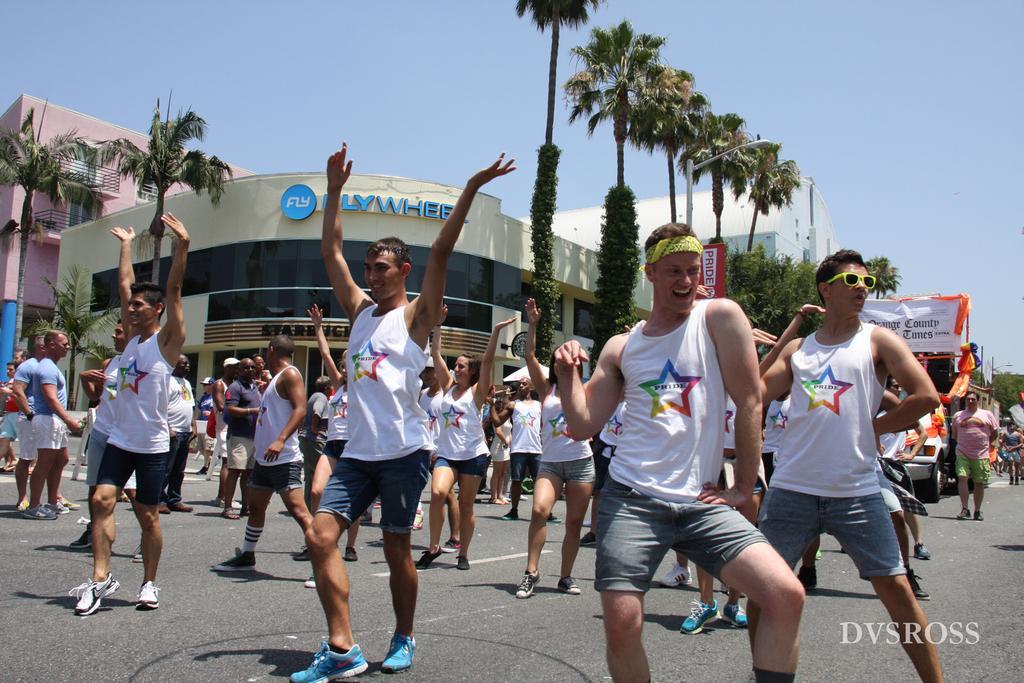Please provide a concise description of this image. In the image I can see a group of people dancing on the floor and there is a smile on their faces. There is a vehicle on the road on the right side. I can see the light poles on the side of the road. In the background, I can see the buildings and trees. The sky is cloudy. 